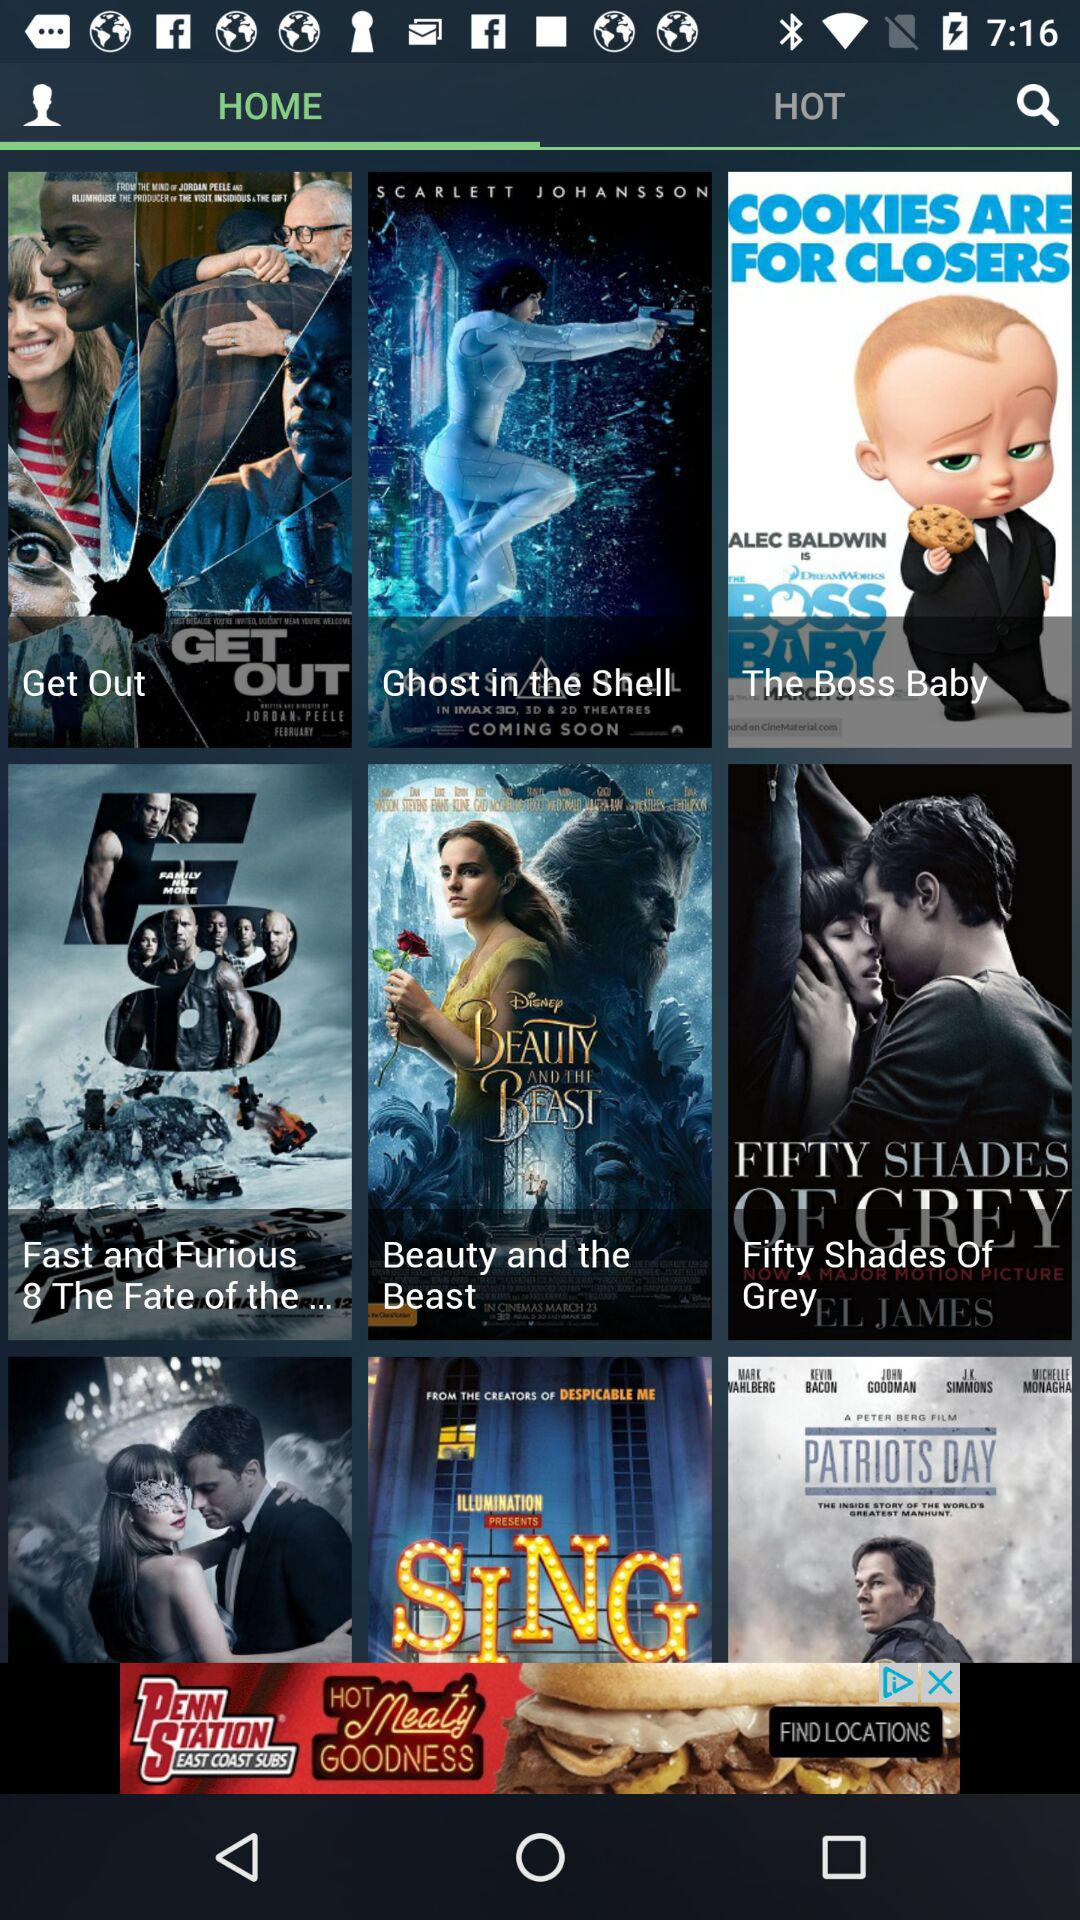Who directed "The Boss Baby"?
When the provided information is insufficient, respond with <no answer>. <no answer> 